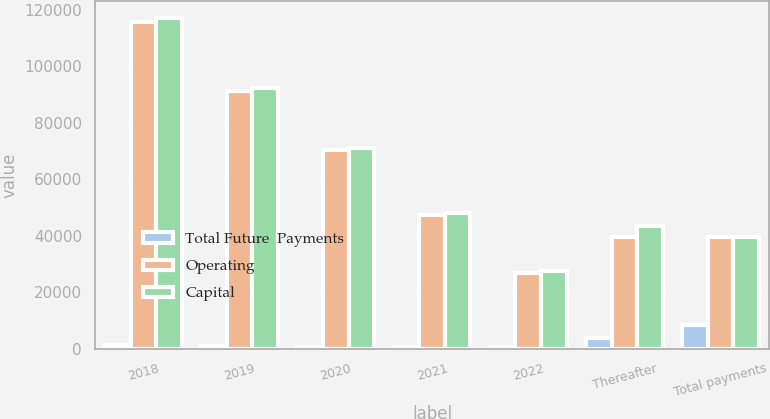Convert chart to OTSL. <chart><loc_0><loc_0><loc_500><loc_500><stacked_bar_chart><ecel><fcel>2018<fcel>2019<fcel>2020<fcel>2021<fcel>2022<fcel>Thereafter<fcel>Total payments<nl><fcel>Total Future  Payments<fcel>1433<fcel>1094<fcel>769<fcel>597<fcel>590<fcel>3954<fcel>8437<nl><fcel>Operating<fcel>115736<fcel>91226<fcel>70146<fcel>47356<fcel>26927<fcel>39615<fcel>39615<nl><fcel>Capital<fcel>117169<fcel>92320<fcel>70915<fcel>47953<fcel>27517<fcel>43569<fcel>39615<nl></chart> 